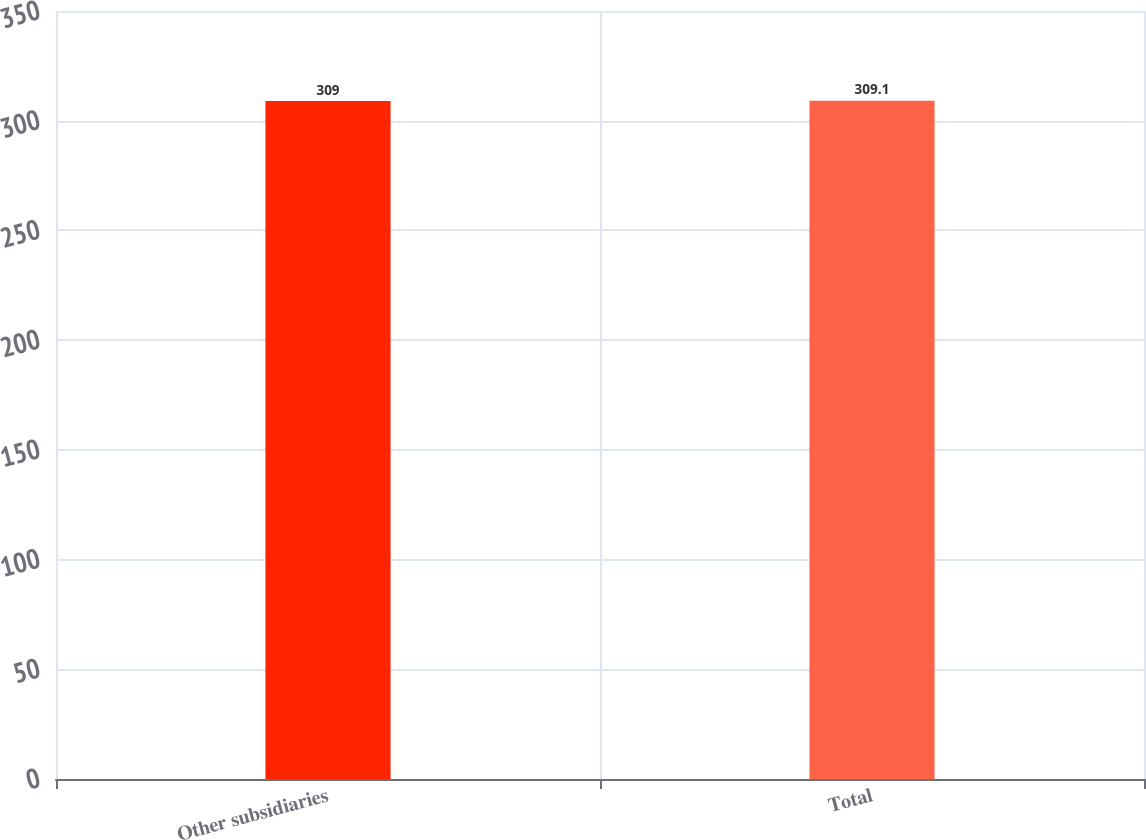<chart> <loc_0><loc_0><loc_500><loc_500><bar_chart><fcel>Other subsidiaries<fcel>Total<nl><fcel>309<fcel>309.1<nl></chart> 